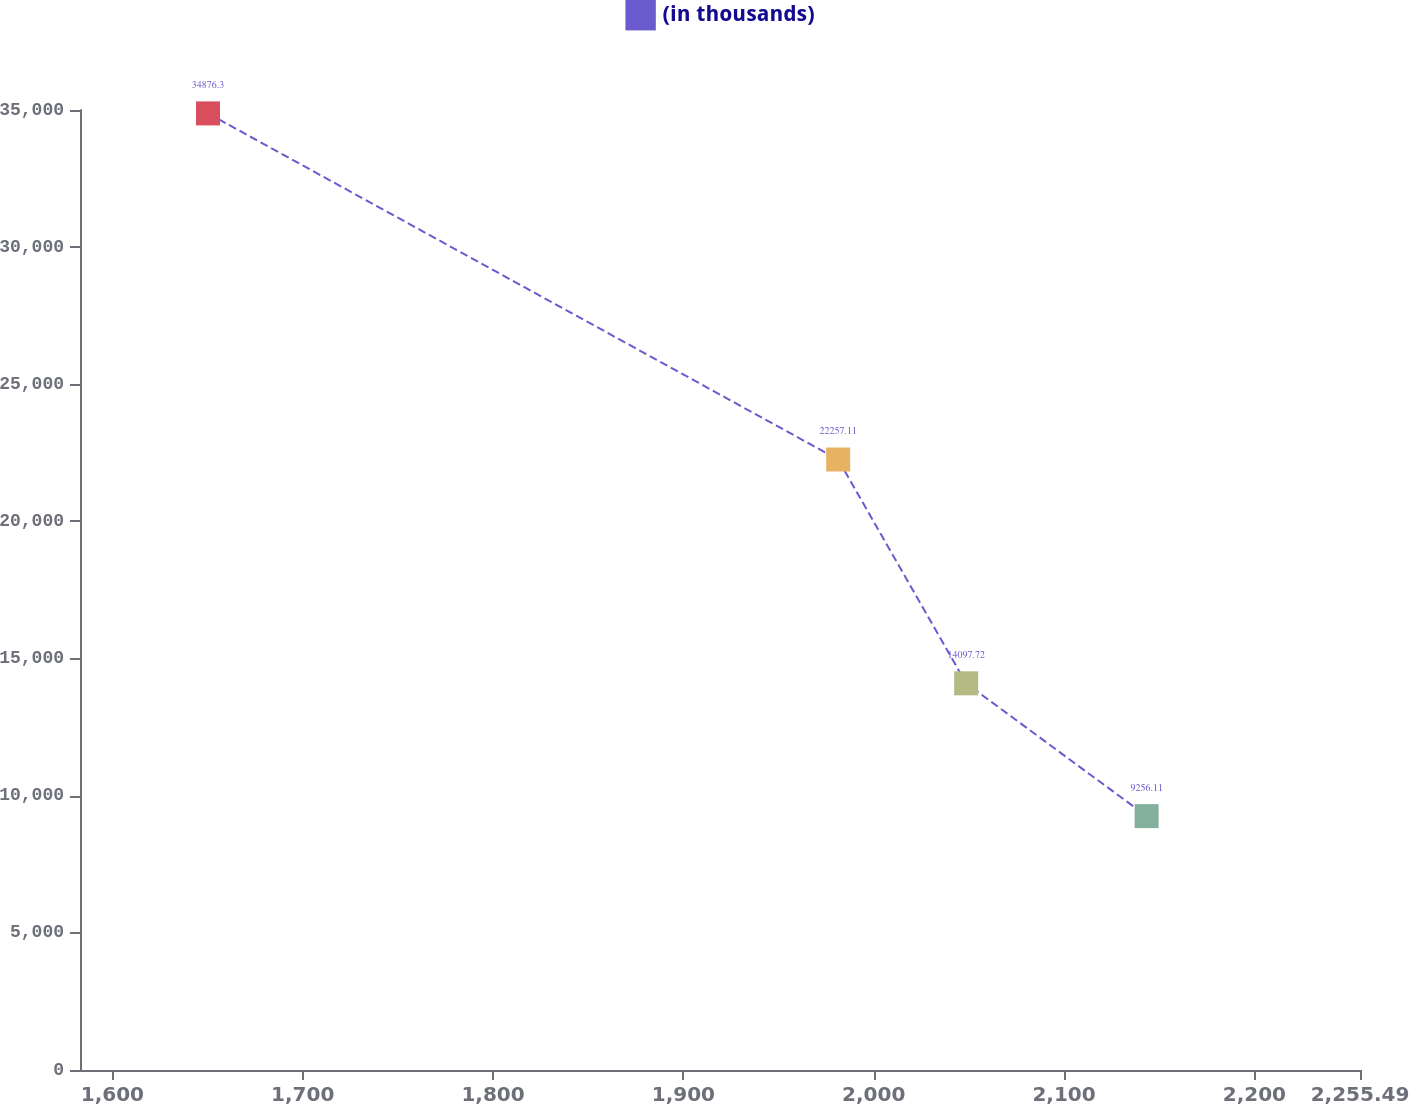Convert chart to OTSL. <chart><loc_0><loc_0><loc_500><loc_500><line_chart><ecel><fcel>(in thousands)<nl><fcel>1650.24<fcel>34876.3<nl><fcel>1981.32<fcel>22257.1<nl><fcel>2048.57<fcel>14097.7<nl><fcel>2143.39<fcel>9256.11<nl><fcel>2322.74<fcel>4209.41<nl></chart> 